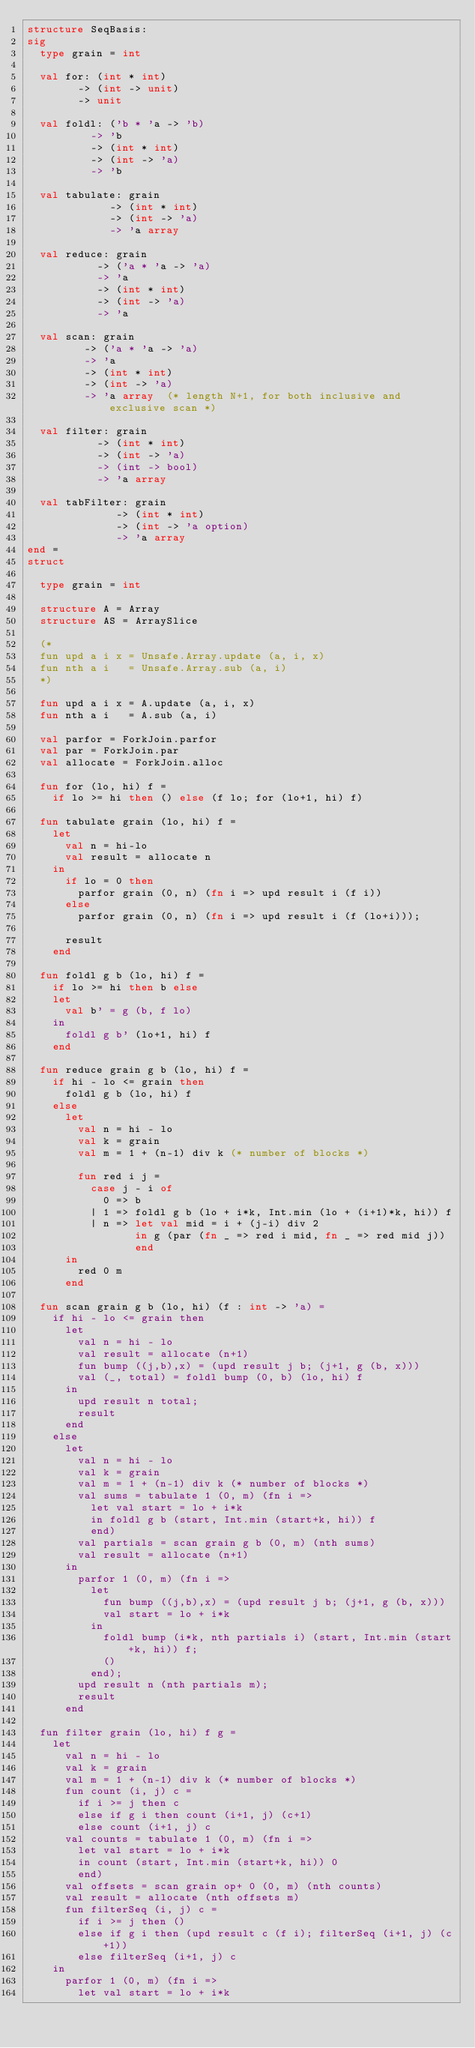<code> <loc_0><loc_0><loc_500><loc_500><_SML_>structure SeqBasis:
sig
  type grain = int

  val for: (int * int)
        -> (int -> unit)
        -> unit

  val foldl: ('b * 'a -> 'b)
          -> 'b
          -> (int * int)
          -> (int -> 'a)
          -> 'b

  val tabulate: grain
             -> (int * int)
             -> (int -> 'a)
             -> 'a array

  val reduce: grain
           -> ('a * 'a -> 'a)
           -> 'a
           -> (int * int)
           -> (int -> 'a)
           -> 'a

  val scan: grain
         -> ('a * 'a -> 'a)
         -> 'a
         -> (int * int)
         -> (int -> 'a)
         -> 'a array  (* length N+1, for both inclusive and exclusive scan *)

  val filter: grain
           -> (int * int)
           -> (int -> 'a)
           -> (int -> bool)
           -> 'a array

  val tabFilter: grain
              -> (int * int)
              -> (int -> 'a option)
              -> 'a array
end =
struct

  type grain = int

  structure A = Array
  structure AS = ArraySlice

  (*
  fun upd a i x = Unsafe.Array.update (a, i, x)
  fun nth a i   = Unsafe.Array.sub (a, i)
  *)

  fun upd a i x = A.update (a, i, x)
  fun nth a i   = A.sub (a, i)

  val parfor = ForkJoin.parfor
  val par = ForkJoin.par
  val allocate = ForkJoin.alloc

  fun for (lo, hi) f =
    if lo >= hi then () else (f lo; for (lo+1, hi) f)

  fun tabulate grain (lo, hi) f =
    let
      val n = hi-lo
      val result = allocate n
    in
      if lo = 0 then
        parfor grain (0, n) (fn i => upd result i (f i))
      else
        parfor grain (0, n) (fn i => upd result i (f (lo+i)));

      result
    end

  fun foldl g b (lo, hi) f =
    if lo >= hi then b else
    let
      val b' = g (b, f lo)
    in
      foldl g b' (lo+1, hi) f
    end

  fun reduce grain g b (lo, hi) f =
    if hi - lo <= grain then
      foldl g b (lo, hi) f
    else
      let
        val n = hi - lo
        val k = grain
        val m = 1 + (n-1) div k (* number of blocks *)

        fun red i j =
          case j - i of
            0 => b
          | 1 => foldl g b (lo + i*k, Int.min (lo + (i+1)*k, hi)) f
          | n => let val mid = i + (j-i) div 2
                 in g (par (fn _ => red i mid, fn _ => red mid j))
                 end
      in
        red 0 m
      end

  fun scan grain g b (lo, hi) (f : int -> 'a) =
    if hi - lo <= grain then
      let
        val n = hi - lo
        val result = allocate (n+1)
        fun bump ((j,b),x) = (upd result j b; (j+1, g (b, x)))
        val (_, total) = foldl bump (0, b) (lo, hi) f
      in
        upd result n total;
        result
      end
    else
      let
        val n = hi - lo
        val k = grain
        val m = 1 + (n-1) div k (* number of blocks *)
        val sums = tabulate 1 (0, m) (fn i =>
          let val start = lo + i*k
          in foldl g b (start, Int.min (start+k, hi)) f
          end)
        val partials = scan grain g b (0, m) (nth sums)
        val result = allocate (n+1)
      in
        parfor 1 (0, m) (fn i =>
          let
            fun bump ((j,b),x) = (upd result j b; (j+1, g (b, x)))
            val start = lo + i*k
          in
            foldl bump (i*k, nth partials i) (start, Int.min (start+k, hi)) f;
            ()
          end);
        upd result n (nth partials m);
        result
      end

  fun filter grain (lo, hi) f g =
    let
      val n = hi - lo
      val k = grain
      val m = 1 + (n-1) div k (* number of blocks *)
      fun count (i, j) c =
        if i >= j then c
        else if g i then count (i+1, j) (c+1)
        else count (i+1, j) c
      val counts = tabulate 1 (0, m) (fn i =>
        let val start = lo + i*k
        in count (start, Int.min (start+k, hi)) 0
        end)
      val offsets = scan grain op+ 0 (0, m) (nth counts)
      val result = allocate (nth offsets m)
      fun filterSeq (i, j) c =
        if i >= j then ()
        else if g i then (upd result c (f i); filterSeq (i+1, j) (c+1))
        else filterSeq (i+1, j) c
    in
      parfor 1 (0, m) (fn i =>
        let val start = lo + i*k</code> 